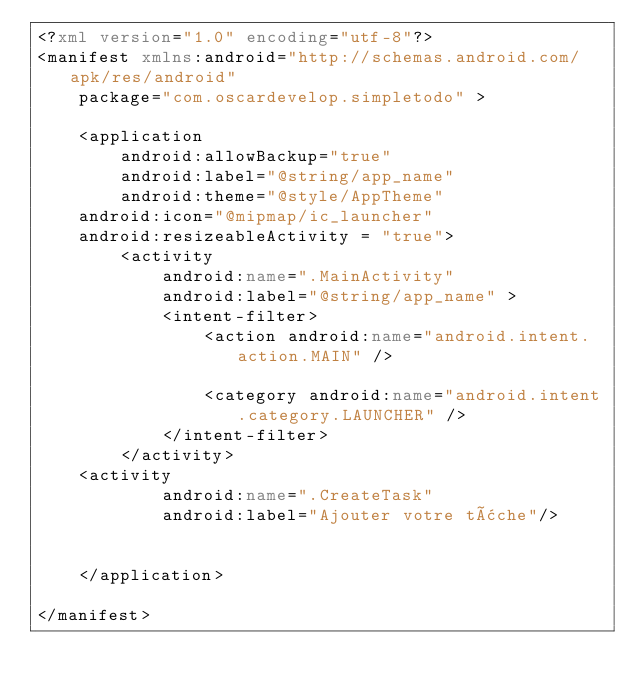<code> <loc_0><loc_0><loc_500><loc_500><_XML_><?xml version="1.0" encoding="utf-8"?>
<manifest xmlns:android="http://schemas.android.com/apk/res/android"
    package="com.oscardevelop.simpletodo" >

    <application
        android:allowBackup="true"
        android:label="@string/app_name"
        android:theme="@style/AppTheme"
		android:icon="@mipmap/ic_launcher"
		android:resizeableActivity = "true">
        <activity
            android:name=".MainActivity"
            android:label="@string/app_name" >
            <intent-filter>
                <action android:name="android.intent.action.MAIN" />

                <category android:name="android.intent.category.LAUNCHER" />
            </intent-filter>
        </activity>
		<activity
            android:name=".CreateTask"
            android:label="Ajouter votre tâche"/>
        
		 
    </application>

</manifest>
</code> 